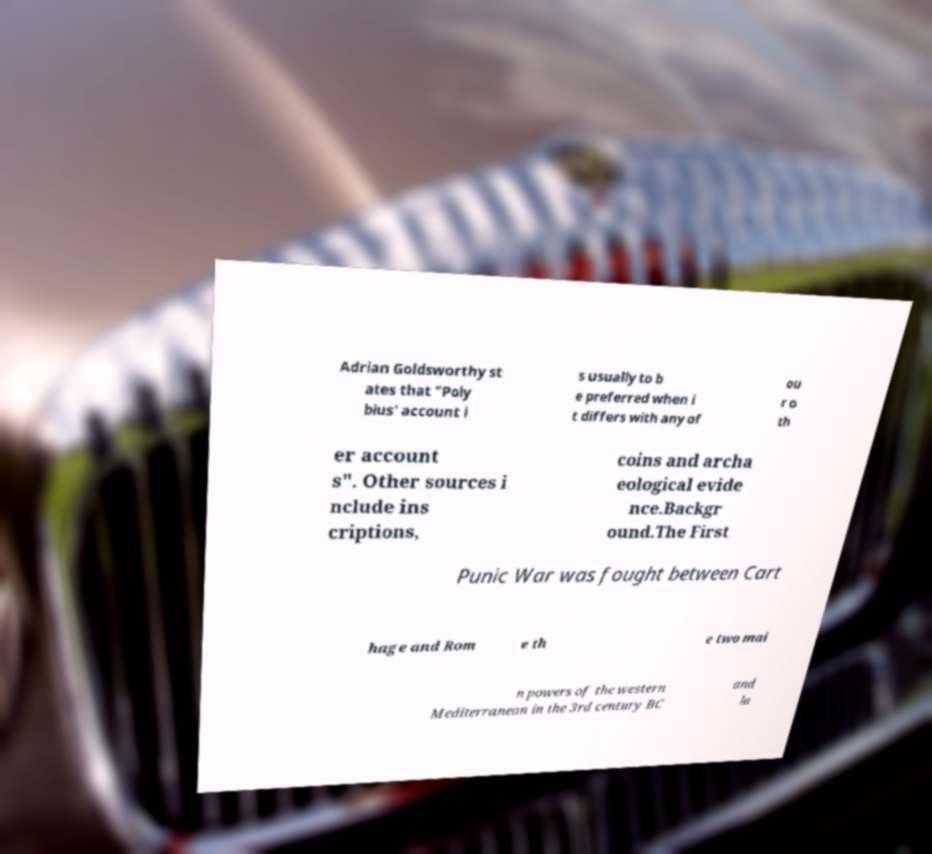There's text embedded in this image that I need extracted. Can you transcribe it verbatim? Adrian Goldsworthy st ates that "Poly bius' account i s usually to b e preferred when i t differs with any of ou r o th er account s". Other sources i nclude ins criptions, coins and archa eological evide nce.Backgr ound.The First Punic War was fought between Cart hage and Rom e th e two mai n powers of the western Mediterranean in the 3rd century BC and la 